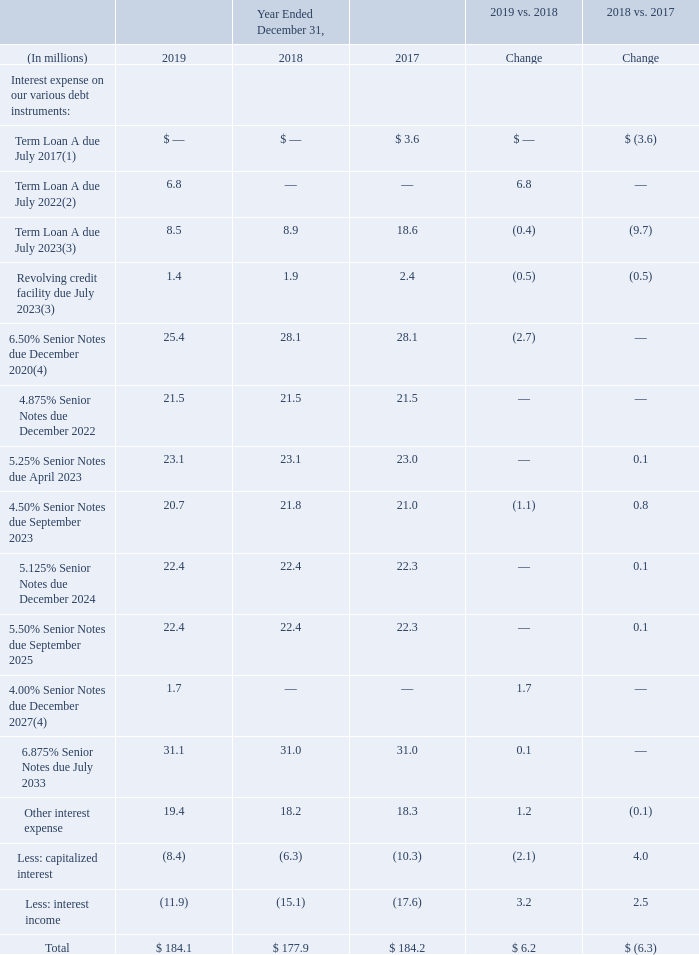Interest expense, net includes the stated interest rate on our outstanding debt, as well as the net impact of capitalized interest, interest income, the effects of terminated interest rate swaps and the amortization of capitalized senior debt issuance costs and credit facility fees, bond discounts, and terminated treasury locks.
Interest expense, net for the years ended December 31, was as follows:
(1) We repaid the notes upon maturity in July 2017.
(2) On August 1, 2019, Sealed Air Corporation, on behalf of itself and certain of its subsidiaries, and Sealed Air Corporation (US) entered into an amendment to its existing senior secured credit facility with Bank of America, N.A., as agent, and the other financial institutions party thereto. The amendment provided for a new incremental term facility in an aggregate principal amount of up to $475 million, to be used, in part, to finance the acquisition of Automated. See Note 14, "Debt and Credit Facilities," of the Notes to Consolidated Financial Statements for further details.
(3) On July 12, 2018, the Company and certain of its subsidiaries entered into a third amended and restated credit agreement with respect to its existing senior secured credit facility. See Note 14, “Debt and Credit Facilities,” of the Notes to Consolidated Financial Statements for further details.
(4) In November 2019, the Company issued $425 million of 4.00% Senior Notes due 2027 and used the proceeds to retire the existing $425 million of 6.50% Senior Notes due 2020. See Note 14, "Debt and Credit Facilities," of the Notes to Consolidated Financial Statements for further details.
What does the table show? Interest expense, net for the years ended december 31. What does Interest expense, net include? Interest expense, net includes the stated interest rate on our outstanding debt, as well as the net impact of capitalized interest, interest income, the effects of terminated interest rate swaps and the amortization of capitalized senior debt issuance costs and credit facility fees, bond discounts, and terminated treasury locks. In In November 2019, what were the proceeds of issuing $425 million of 4.00% Senior Notes due 2027 used for? Retire the existing $425 million of 6.50% senior notes due 2020. What is the Total interest expense for years 2017-2019?
Answer scale should be: million. 184.1+177.9+184.2
Answer: 546.2. For the year 2019, what is the interest expense for Senior Notes due from 2020-2023 inclusive?
Answer scale should be: million. 25.4+21.5+23.1+20.7
Answer: 90.7. What is the change of the percentage change of Total interest expense from 2018 vs. 2017 to 2019 vs. 2018?
Answer scale should be: percent. (184.1-177.9)/177.9-(177.9-184.2)/184.2
Answer: 6.91. 